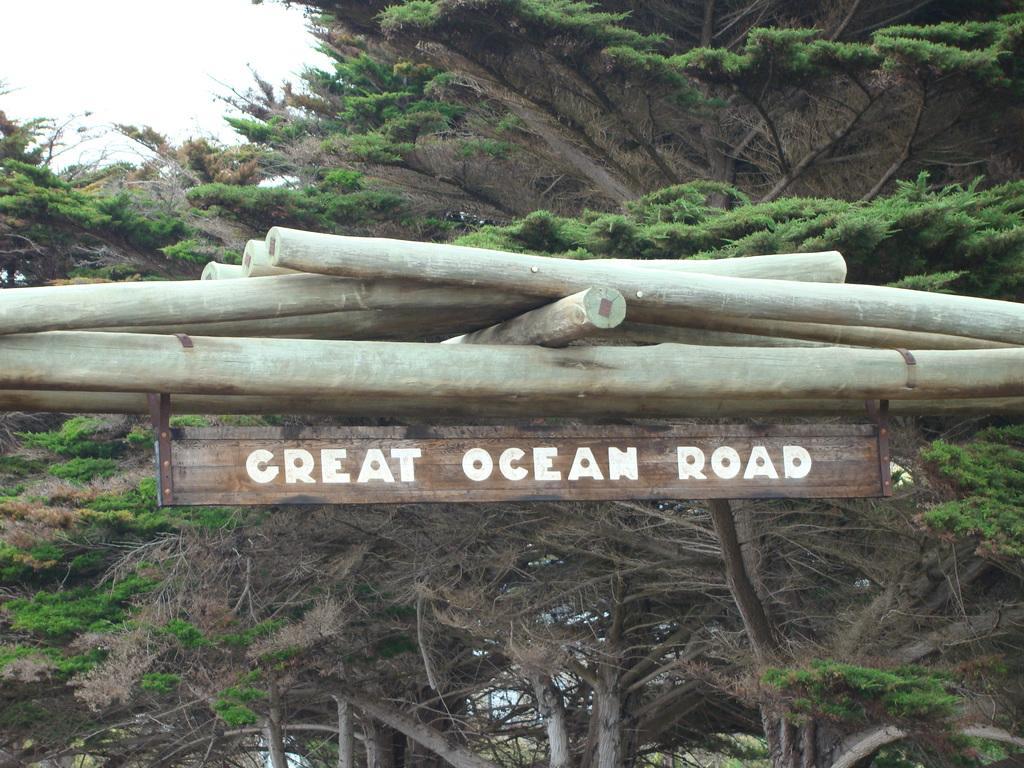How would you summarize this image in a sentence or two? In this picture there is a board on the wooden stick and there is a text on the board. At the back there are trees. At the top there is sky. 